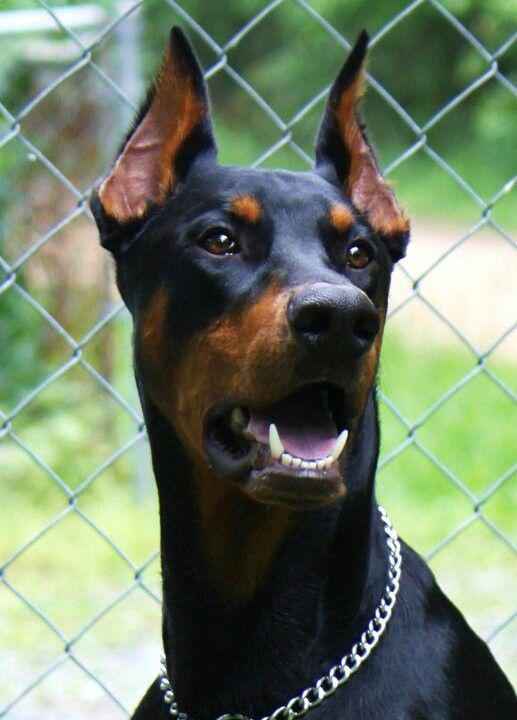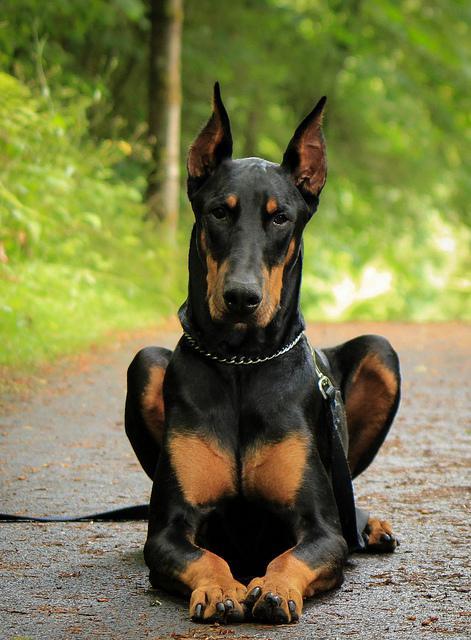The first image is the image on the left, the second image is the image on the right. Analyze the images presented: Is the assertion "The left image features a doberman in a collar with its head in profile facing right, and the right image features a dock-tailed doberman standing on all fours with body angled leftward." valid? Answer yes or no. No. The first image is the image on the left, the second image is the image on the right. For the images displayed, is the sentence "The left image shows a black and brown dog with its mouth open and teeth visible." factually correct? Answer yes or no. Yes. 